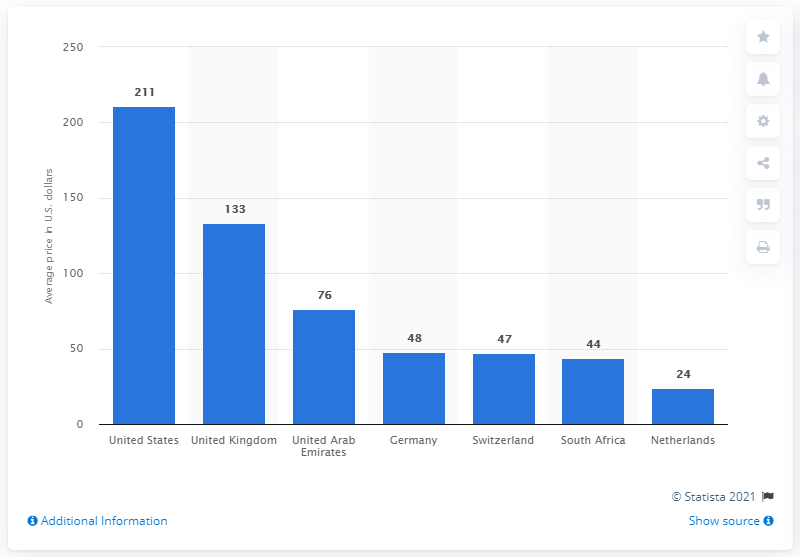Specify some key components in this picture. The average price of Herceptin in the United States in 2017 was $211. 